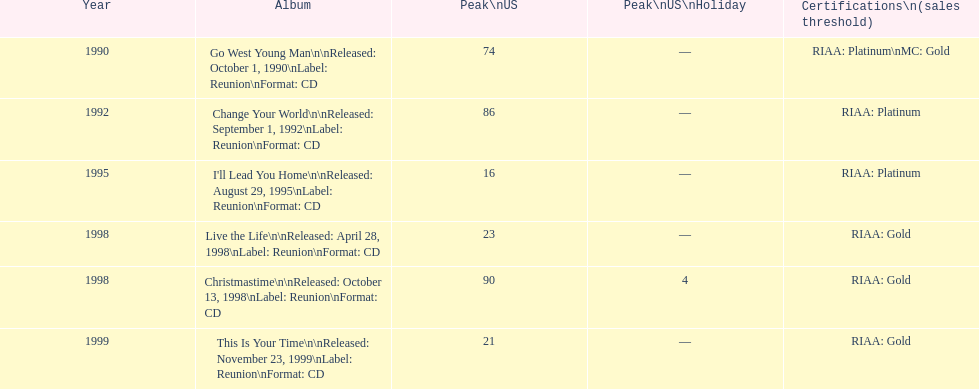Riaa: gold is only one of the certifications, but what is the other? Platinum. 